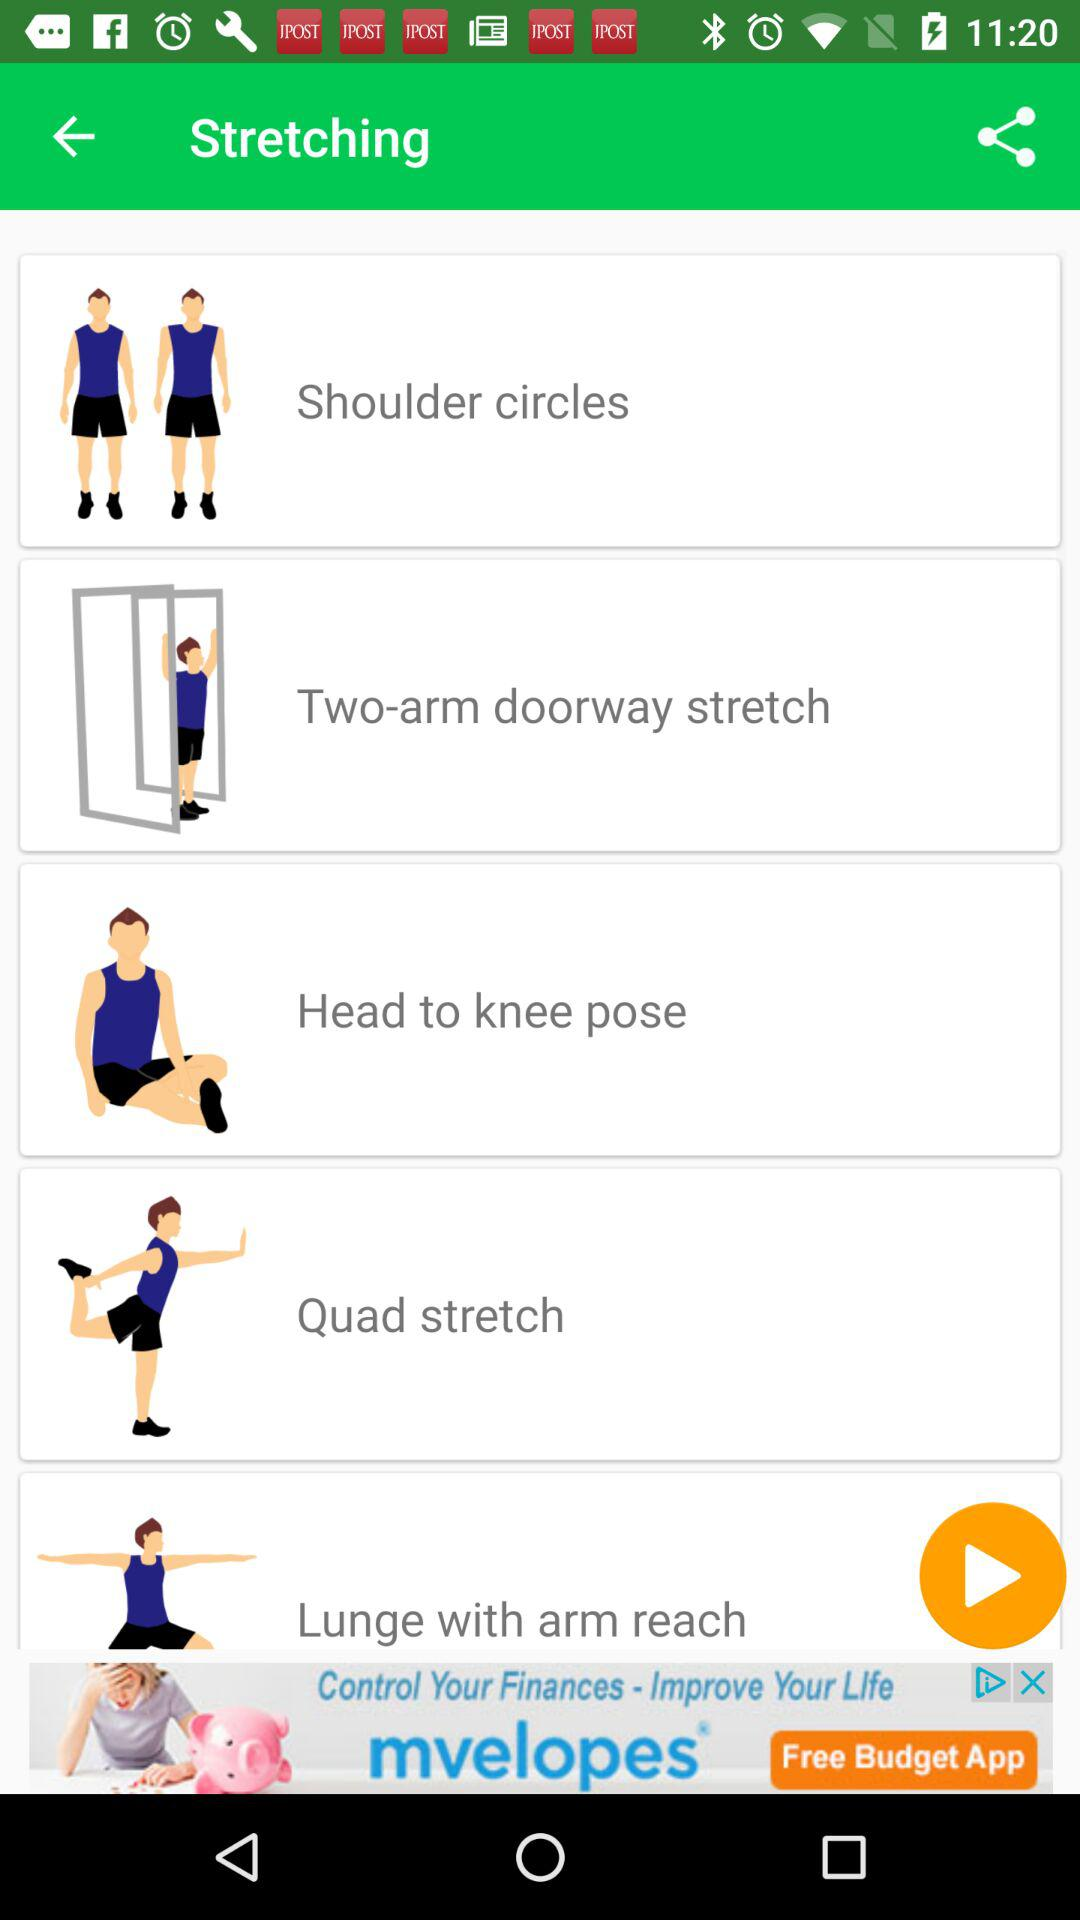How many stretching exercises are there?
Answer the question using a single word or phrase. 5 